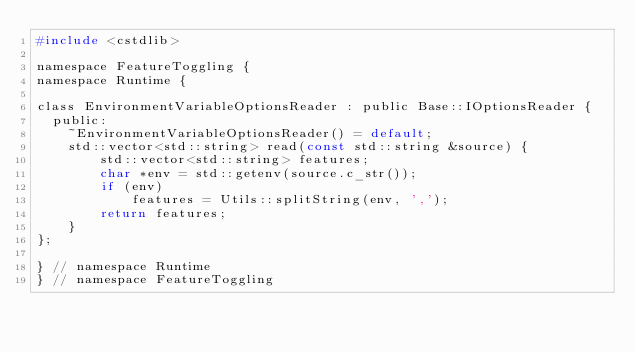<code> <loc_0><loc_0><loc_500><loc_500><_C_>#include <cstdlib>

namespace FeatureToggling {
namespace Runtime {

class EnvironmentVariableOptionsReader : public Base::IOptionsReader {
  public:
    ~EnvironmentVariableOptionsReader() = default;
    std::vector<std::string> read(const std::string &source) {
        std::vector<std::string> features;
        char *env = std::getenv(source.c_str());
        if (env)
            features = Utils::splitString(env, ',');
        return features;
    }
};

} // namespace Runtime
} // namespace FeatureToggling
</code> 